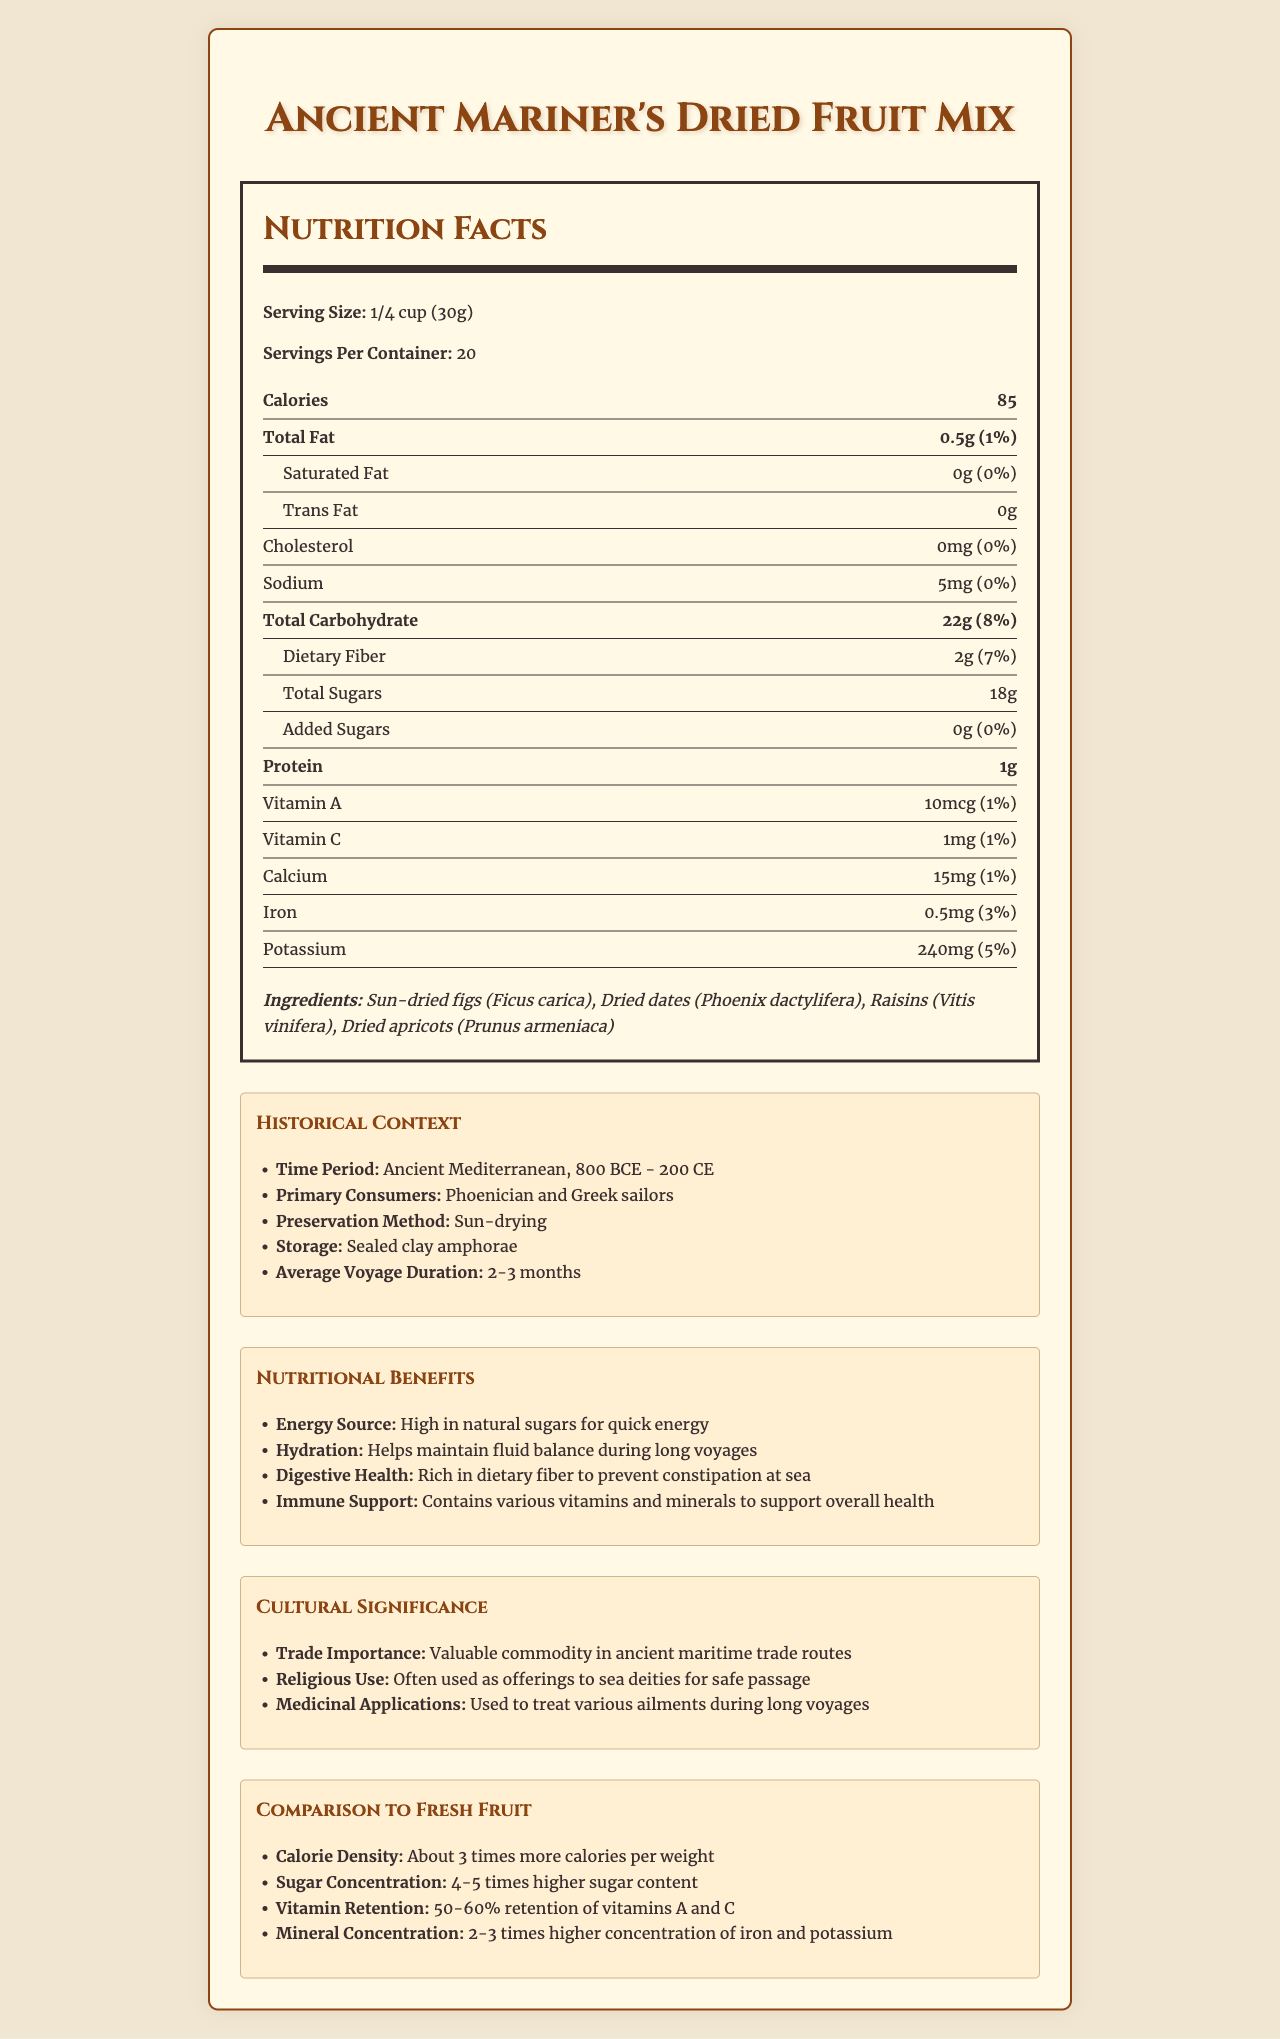what is the serving size of the Ancient Mariner's Dried Fruit Mix? The serving size is clearly stated under "Nutrition Facts" as "1/4 cup (30g)".
Answer: 1/4 cup (30g) How many calories are there per serving? The document specifies "Calories" as 85 per serving.
Answer: 85 Name two primary consumers of this dried fruit mix in ancient times. Under "Historical Context", the primary consumers are listed as "Phoenician and Greek sailors".
Answer: Phoenician and Greek sailors How does the preservation method for this dried fruit mix compare to modern methods? The document states the preservation method is sun-drying. Modern methods often include freeze-drying and other advanced techniques.
Answer: Sun-drying vs modern methods like freeze-drying What is the total carbohydrate content per serving? The total carbohydrate content per serving is listed as 22g.
Answer: 22g Which of the following is NOT an ingredient in the Ancient Mariner's Dried Fruit Mix? A. Sun-dried figs B. Dried dates C. Fresh apples D. Dried apricots Fresh apples are not listed among the ingredients, which are sun-dried figs, dried dates, raisins, and dried apricots.
Answer: C. Fresh apples Which vitamin has the lowest daily value percentage in the mix? A. Vitamin A B. Vitamin C C. Calcium D. Iron Vitamin A has a daily value of 1%, which is the lowest among the listed vitamins and minerals.
Answer: A. Vitamin A True or False: The Ancient Mariner's Dried Fruit Mix contains trans fat. The document specifies "Trans Fat" as 0g, meaning it contains no trans fat.
Answer: False Summarize the nutritional benefits of the Ancient Mariner's Dried Fruit Mix. This summary includes the main points listed under "Nutritional Benefits": energy source, hydration, digestive health, and immune support.
Answer: The Ancient Mariner's Dried Fruit Mix is high in natural sugars for quick energy, helps maintain fluid balance, is rich in dietary fiber to prevent constipation, and contains various vitamins and minerals to support overall health. Why might sailors have preferred dried fruits over fresh fruits during long voyages? Dried fruits are easily preservable through sun-drying and can be stored in sealed clay amphorae. They also have about 3 times more calories per weight compared to fresh fruits, making them more practical for long voyages.
Answer: Longer shelf life and higher calorie density What was the average duration of voyages undertaken by sailors consuming this dried fruit mix? The "Historical Context" section states the average voyage duration as "2-3 months".
Answer: 2-3 months How does the mineral concentration of dried fruits compare to fresh fruits? The document mentions that dried fruits have "2-3 times higher concentration of iron and potassium" compared to fresh fruits.
Answer: 2-3 times higher for dried fruits Is this dried fruit mix used in religious ceremonies? Under "Cultural Significance", it is mentioned that the dried fruit mix was "often used as offerings to sea deities for safe passage".
Answer: Yes How many servings per container are there in this product? The document lists "Servings Per Container" as 20.
Answer: 20 What method was used to preserve the Ancient Mariner's Dried Fruit Mix? The preservation method is listed under "Historical Context" as "sun-drying".
Answer: Sun-drying What is the daily value percentage of dietary fiber in each serving? The dietary fiber content has a daily value percentage of 7%.
Answer: 7% How does the vitamin retention in dried fruits compare to fresh fruits? The document states that dried fruits retain about 50-60% of their vitamins A and C compared to fresh fruits.
Answer: 50-60% retention of vitamins A and C How much iron is there in a serving of this product? The document lists the iron content as 0.5mg per serving.
Answer: 0.5mg What is the significant difference in sugar content between dried and fresh fruits mentioned? The document details that dried fruits have "4-5 times higher sugar content" compared to fresh fruits.
Answer: 4-5 times higher sugar content in dried fruits Did Phoenician and Greek sailors store their dried fruits in barrels? The document mentions storage in sealed clay amphorae but does not provide information on the use of barrels.
Answer: Not enough information 